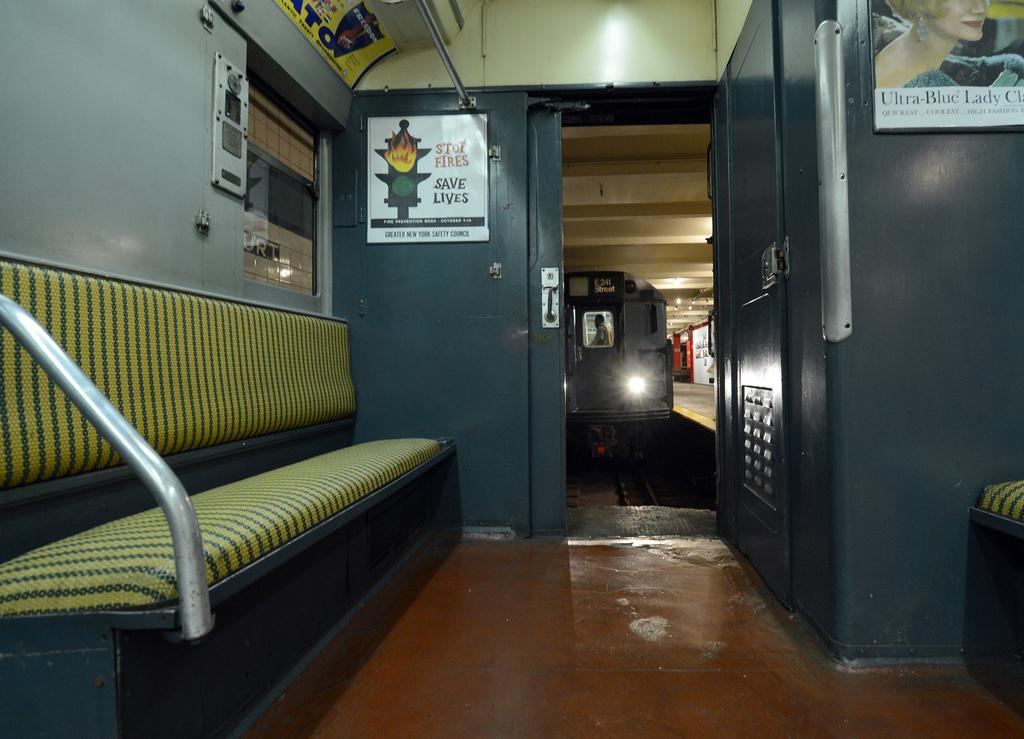<image>
Relay a brief, clear account of the picture shown. a white poster in a room with the word lives on it 